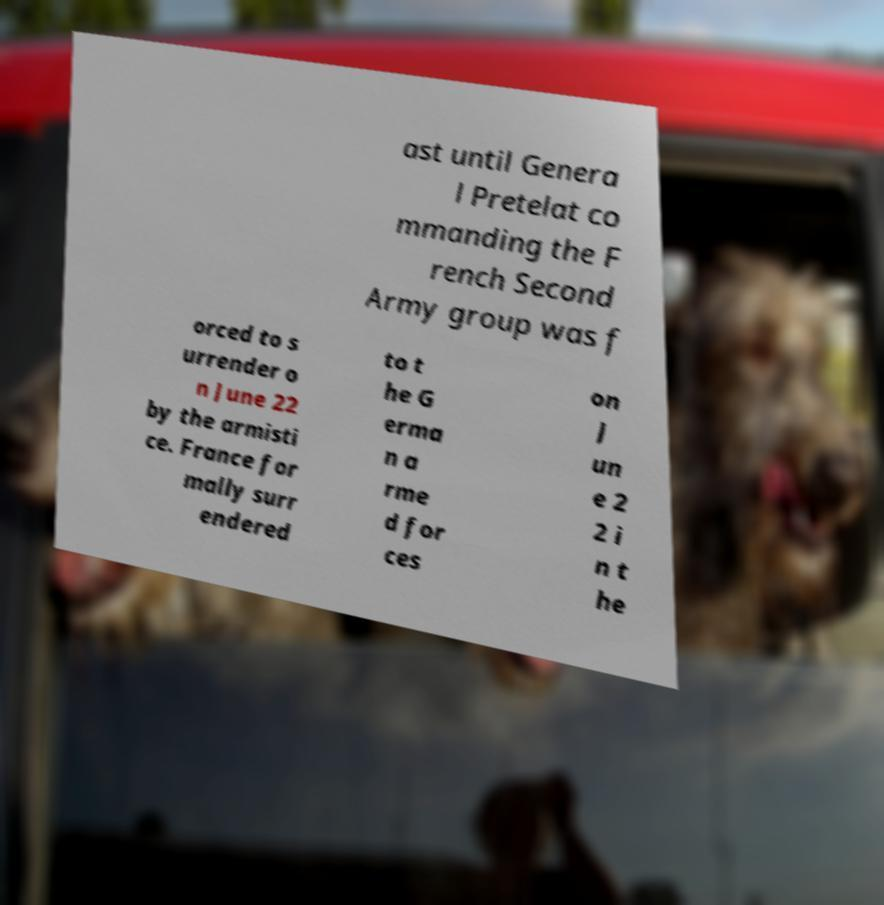Please identify and transcribe the text found in this image. ast until Genera l Pretelat co mmanding the F rench Second Army group was f orced to s urrender o n June 22 by the armisti ce. France for mally surr endered to t he G erma n a rme d for ces on J un e 2 2 i n t he 